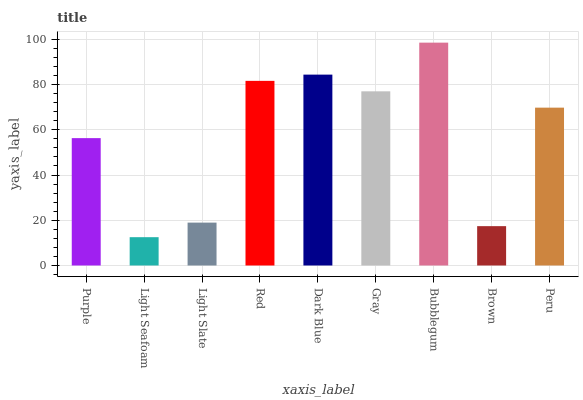Is Light Seafoam the minimum?
Answer yes or no. Yes. Is Bubblegum the maximum?
Answer yes or no. Yes. Is Light Slate the minimum?
Answer yes or no. No. Is Light Slate the maximum?
Answer yes or no. No. Is Light Slate greater than Light Seafoam?
Answer yes or no. Yes. Is Light Seafoam less than Light Slate?
Answer yes or no. Yes. Is Light Seafoam greater than Light Slate?
Answer yes or no. No. Is Light Slate less than Light Seafoam?
Answer yes or no. No. Is Peru the high median?
Answer yes or no. Yes. Is Peru the low median?
Answer yes or no. Yes. Is Dark Blue the high median?
Answer yes or no. No. Is Bubblegum the low median?
Answer yes or no. No. 